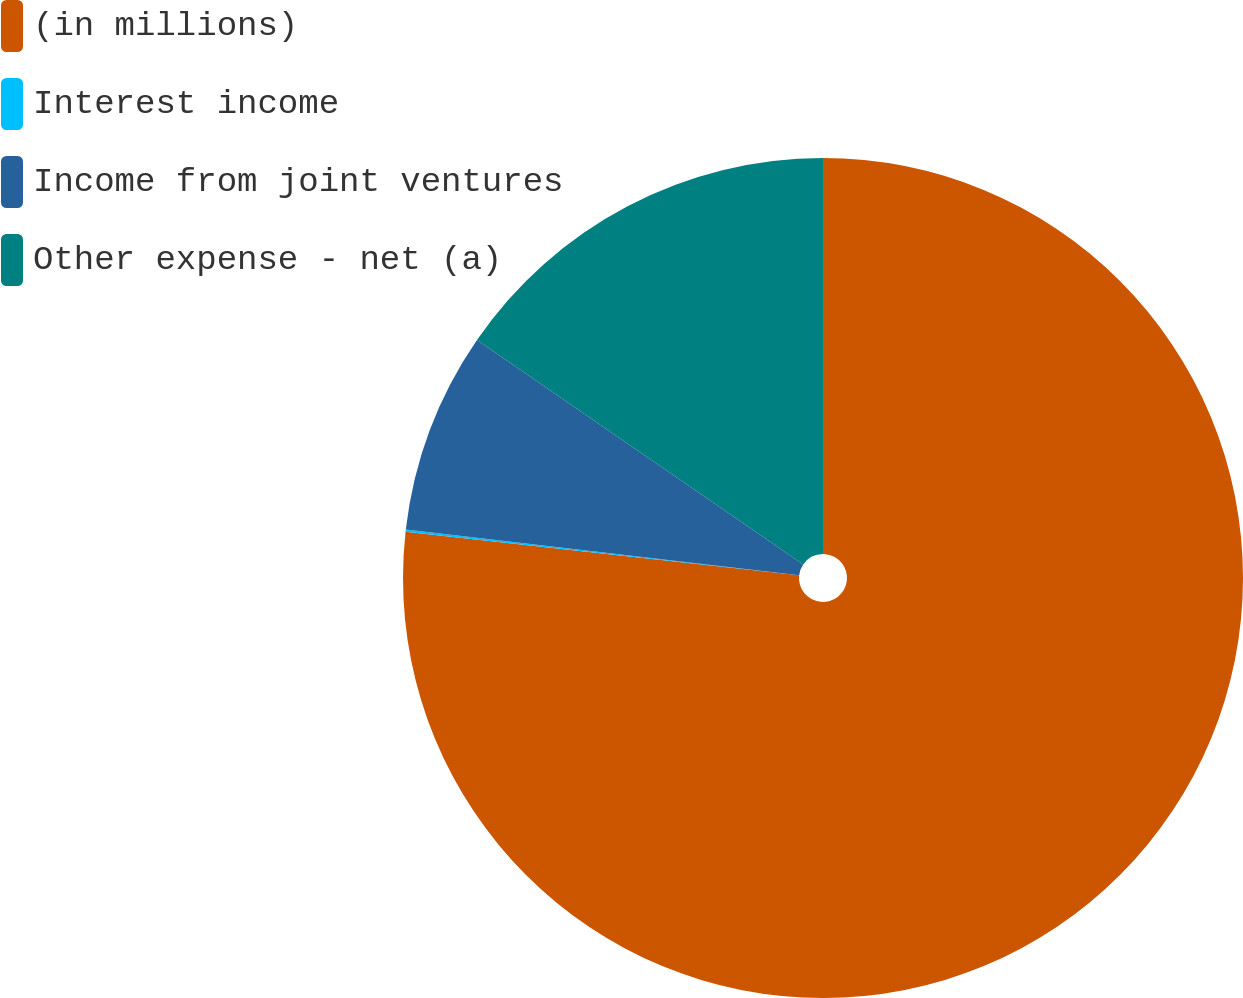<chart> <loc_0><loc_0><loc_500><loc_500><pie_chart><fcel>(in millions)<fcel>Interest income<fcel>Income from joint ventures<fcel>Other expense - net (a)<nl><fcel>76.76%<fcel>0.08%<fcel>7.75%<fcel>15.41%<nl></chart> 